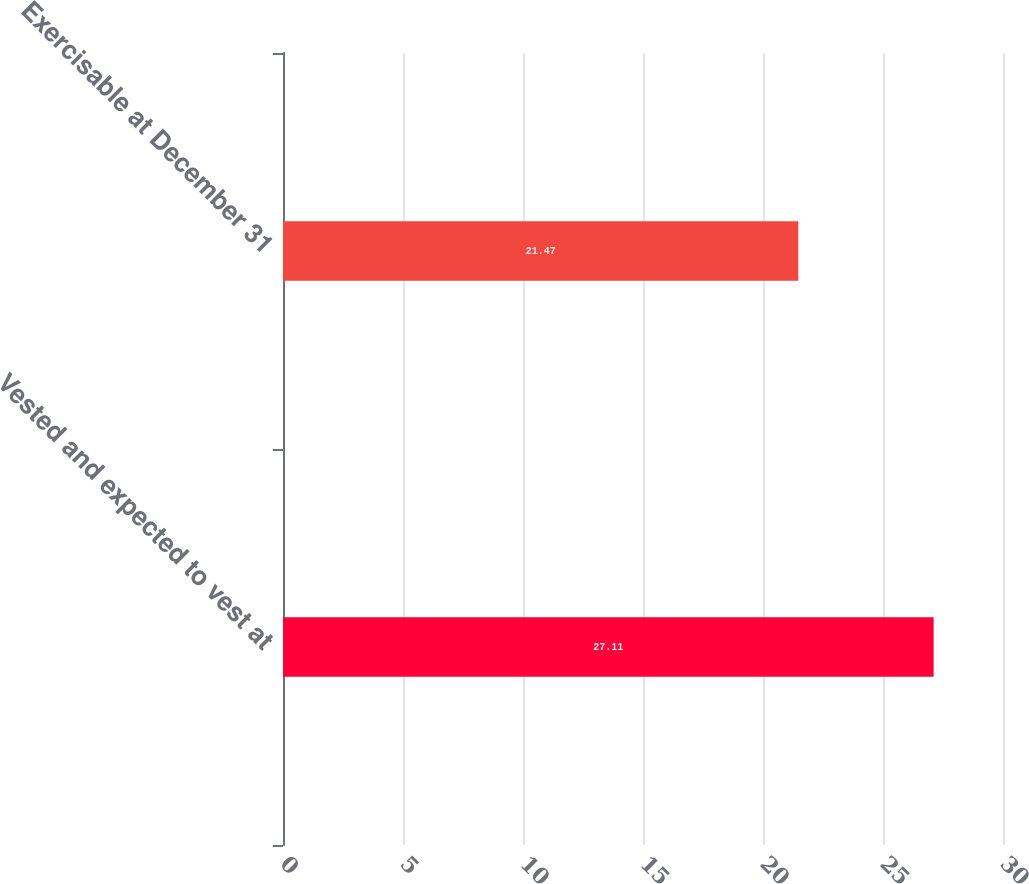Convert chart to OTSL. <chart><loc_0><loc_0><loc_500><loc_500><bar_chart><fcel>Vested and expected to vest at<fcel>Exercisable at December 31<nl><fcel>27.11<fcel>21.47<nl></chart> 